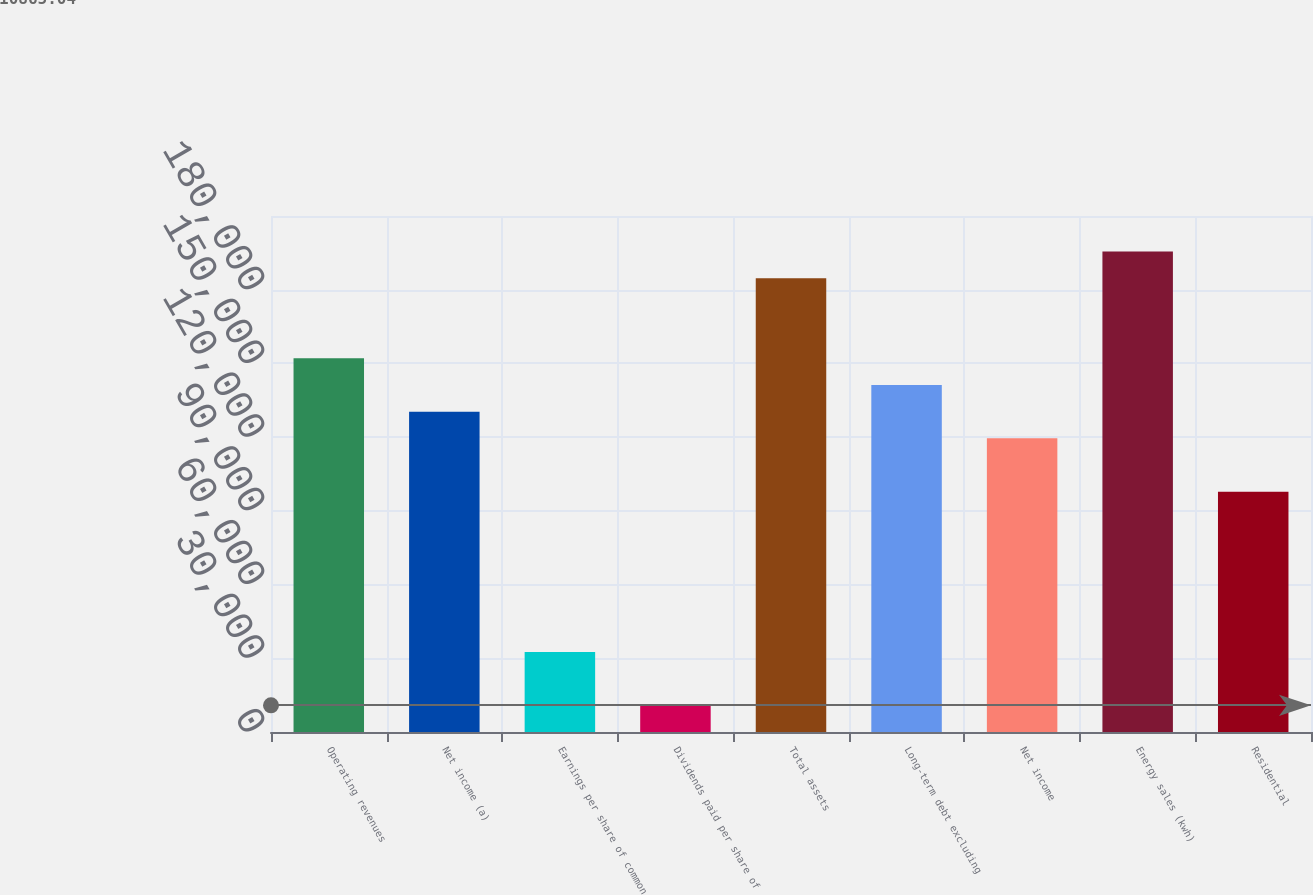Convert chart to OTSL. <chart><loc_0><loc_0><loc_500><loc_500><bar_chart><fcel>Operating revenues<fcel>Net income (a)<fcel>Earnings per share of common<fcel>Dividends paid per share of<fcel>Total assets<fcel>Long-term debt excluding<fcel>Net income<fcel>Energy sales (kwh)<fcel>Residential<nl><fcel>152090<fcel>130363<fcel>32591.9<fcel>10865<fcel>184680<fcel>141226<fcel>119499<fcel>195544<fcel>97772.6<nl></chart> 